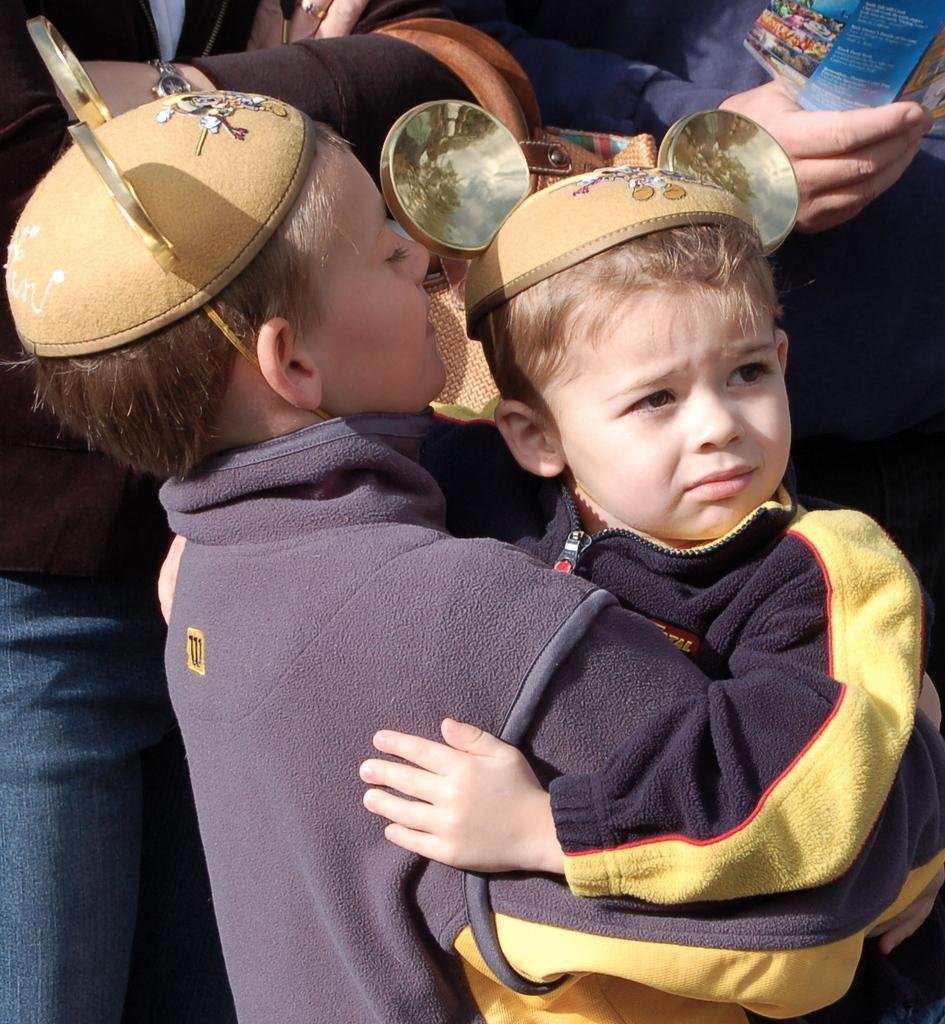Can you describe this image briefly? There are people and these two kids wore caps. 